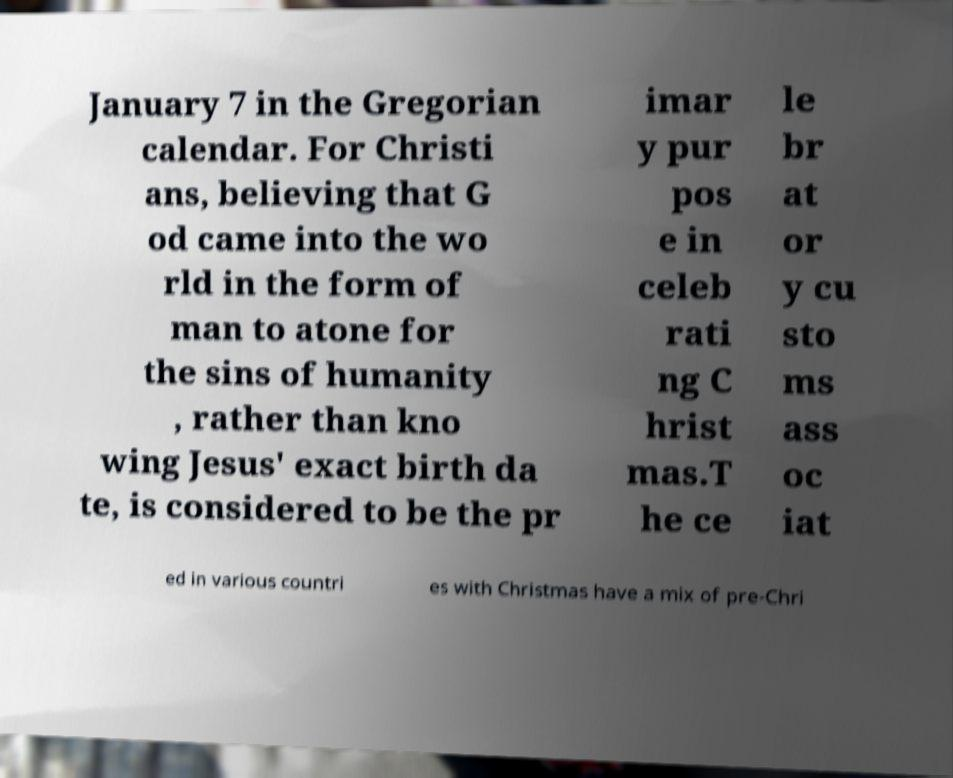What messages or text are displayed in this image? I need them in a readable, typed format. January 7 in the Gregorian calendar. For Christi ans, believing that G od came into the wo rld in the form of man to atone for the sins of humanity , rather than kno wing Jesus' exact birth da te, is considered to be the pr imar y pur pos e in celeb rati ng C hrist mas.T he ce le br at or y cu sto ms ass oc iat ed in various countri es with Christmas have a mix of pre-Chri 